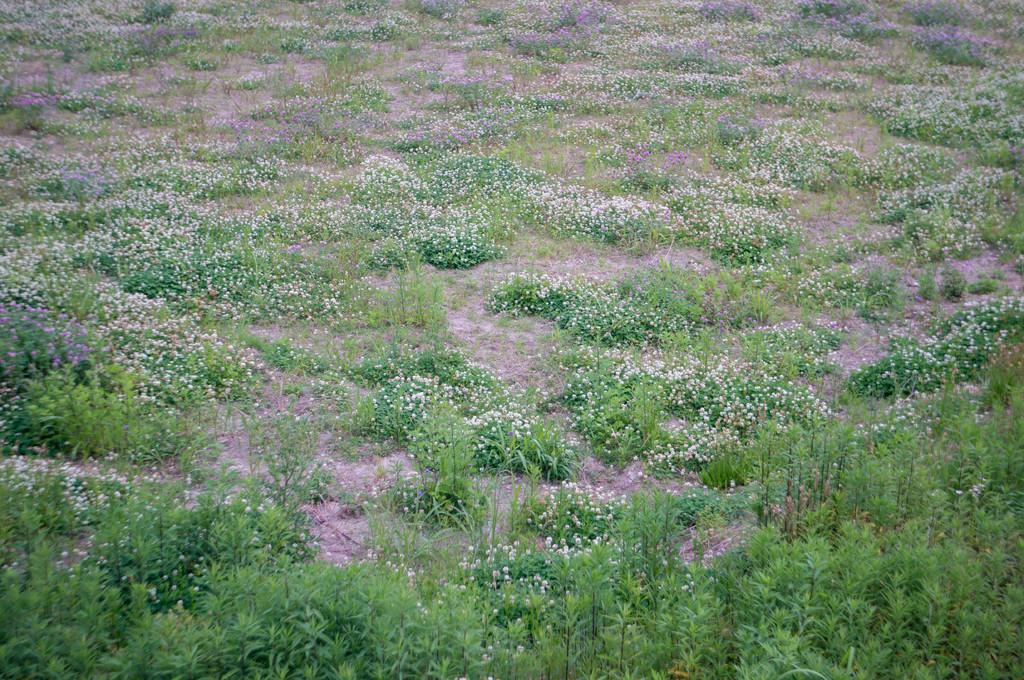What type of vegetation is visible on the ground in the image? There is grass on the ground in the image. What type of shoes can be seen in the grassy scene? There are no shoes present in the image; it only features grass on the ground. 